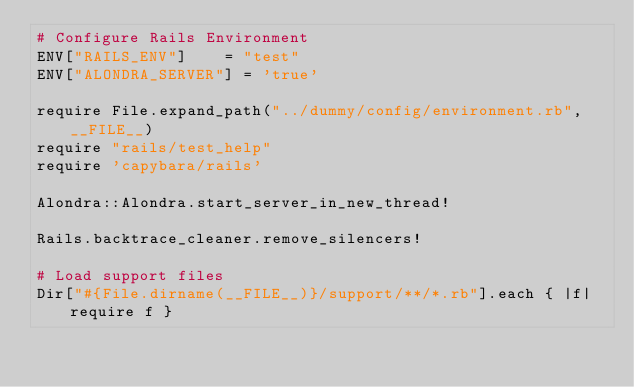Convert code to text. <code><loc_0><loc_0><loc_500><loc_500><_Ruby_># Configure Rails Environment
ENV["RAILS_ENV"]    = "test"
ENV["ALONDRA_SERVER"] = 'true'

require File.expand_path("../dummy/config/environment.rb",  __FILE__)
require "rails/test_help"
require 'capybara/rails'

Alondra::Alondra.start_server_in_new_thread!

Rails.backtrace_cleaner.remove_silencers!

# Load support files
Dir["#{File.dirname(__FILE__)}/support/**/*.rb"].each { |f| require f }
</code> 